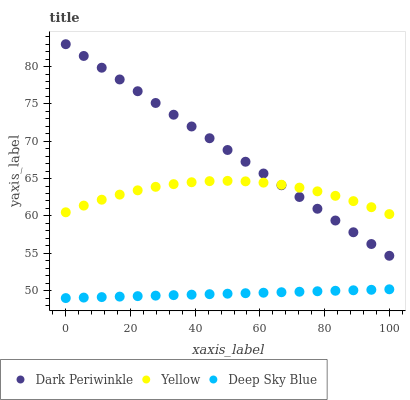Does Deep Sky Blue have the minimum area under the curve?
Answer yes or no. Yes. Does Dark Periwinkle have the maximum area under the curve?
Answer yes or no. Yes. Does Yellow have the minimum area under the curve?
Answer yes or no. No. Does Yellow have the maximum area under the curve?
Answer yes or no. No. Is Deep Sky Blue the smoothest?
Answer yes or no. Yes. Is Yellow the roughest?
Answer yes or no. Yes. Is Dark Periwinkle the smoothest?
Answer yes or no. No. Is Dark Periwinkle the roughest?
Answer yes or no. No. Does Deep Sky Blue have the lowest value?
Answer yes or no. Yes. Does Dark Periwinkle have the lowest value?
Answer yes or no. No. Does Dark Periwinkle have the highest value?
Answer yes or no. Yes. Does Yellow have the highest value?
Answer yes or no. No. Is Deep Sky Blue less than Yellow?
Answer yes or no. Yes. Is Yellow greater than Deep Sky Blue?
Answer yes or no. Yes. Does Dark Periwinkle intersect Yellow?
Answer yes or no. Yes. Is Dark Periwinkle less than Yellow?
Answer yes or no. No. Is Dark Periwinkle greater than Yellow?
Answer yes or no. No. Does Deep Sky Blue intersect Yellow?
Answer yes or no. No. 